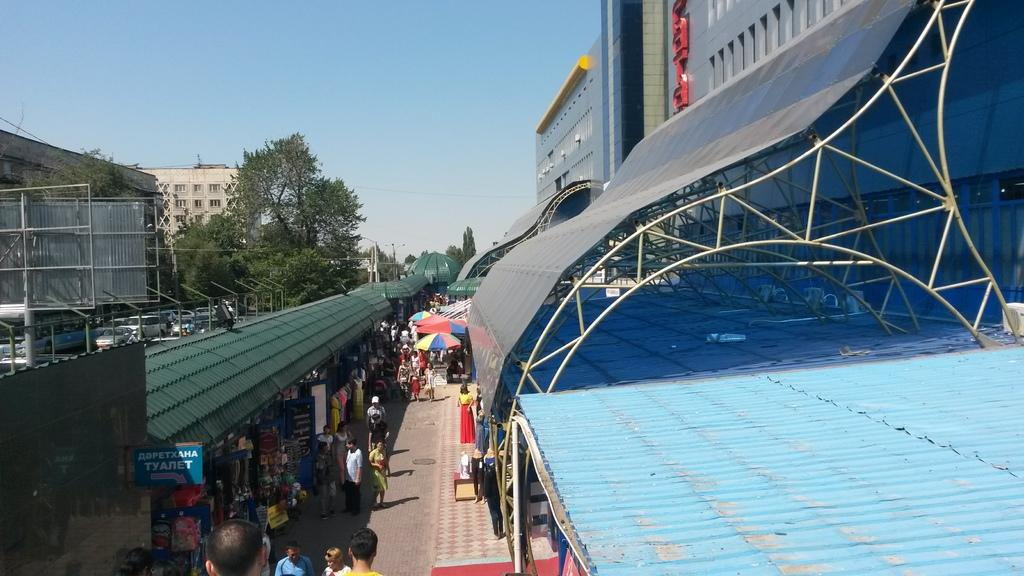How many people are at the bottom of the image? There are many people at the bottom of the image. What are the people at the bottom of the image holding? Umbrellas are present at the bottom of the image. What is the location of the people at the bottom of the image? They are on a platform at the bottom of the image. What is the structure above the platform at the bottom of the image? A roof is visible at the bottom of the image. What can be seen in the middle of the image? Trees, buildings, cars, poles, and the sky are visible in the middle of the image. How does the disgust feel in the image? There is no mention of disgust in the image, so it cannot be felt or experienced. What type of neck is visible in the image? There is no neck present in the image. 